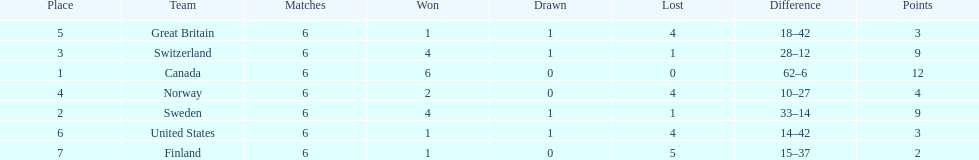What was the sum of points achieved by great britain? 3. 